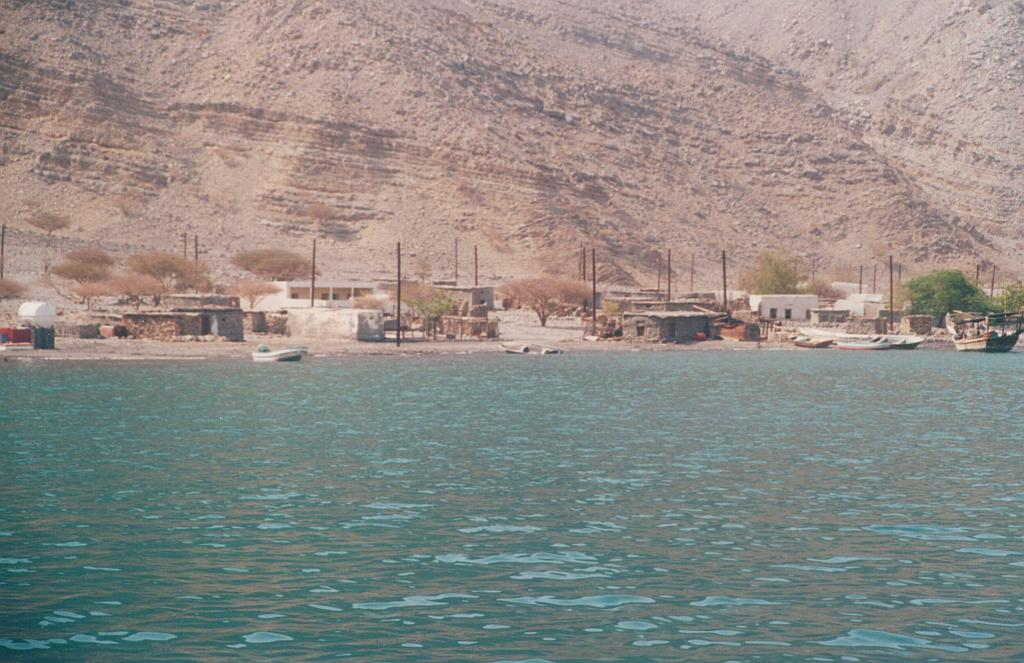What can be seen in the image that is used for transportation on water? There are boats in the image that are used for transportation on water. Where are the boats located in the image? The boats are on a river in the image. What can be seen on the other side of the river? There are trees, houses, and poles on the other side of the river. What is visible in the background behind the houses, trees, and poles? There is a mountain visible behind the houses, trees, and poles. What type of cap is the mist wearing in the image? There is no mist or cap present in the image. How many cubs are playing with the boats in the image? There are no cubs present in the image; it features boats on a river with trees, houses, and poles on the other side. 